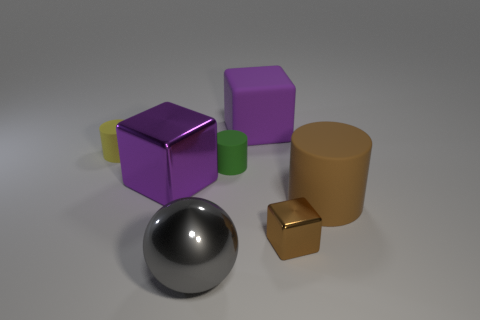Subtract all brown metallic cubes. How many cubes are left? 2 Add 3 big red cylinders. How many objects exist? 10 Subtract all red cylinders. How many purple blocks are left? 2 Subtract all cylinders. How many objects are left? 4 Subtract all yellow blocks. Subtract all cyan cylinders. How many blocks are left? 3 Subtract all purple cubes. Subtract all large objects. How many objects are left? 1 Add 7 large brown things. How many large brown things are left? 8 Add 7 small metallic objects. How many small metallic objects exist? 8 Subtract all purple cubes. How many cubes are left? 1 Subtract 0 red spheres. How many objects are left? 7 